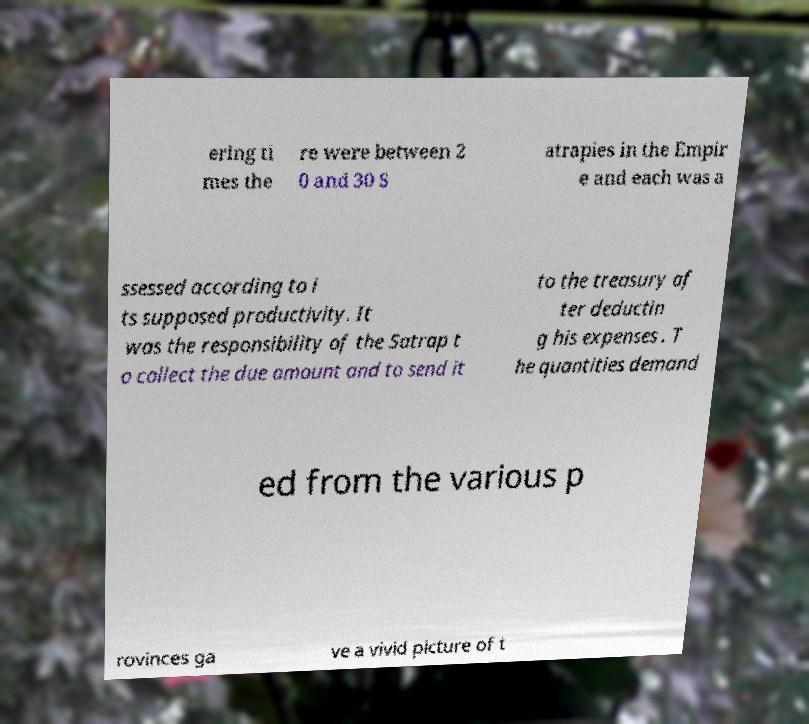Could you extract and type out the text from this image? ering ti mes the re were between 2 0 and 30 S atrapies in the Empir e and each was a ssessed according to i ts supposed productivity. It was the responsibility of the Satrap t o collect the due amount and to send it to the treasury af ter deductin g his expenses . T he quantities demand ed from the various p rovinces ga ve a vivid picture of t 